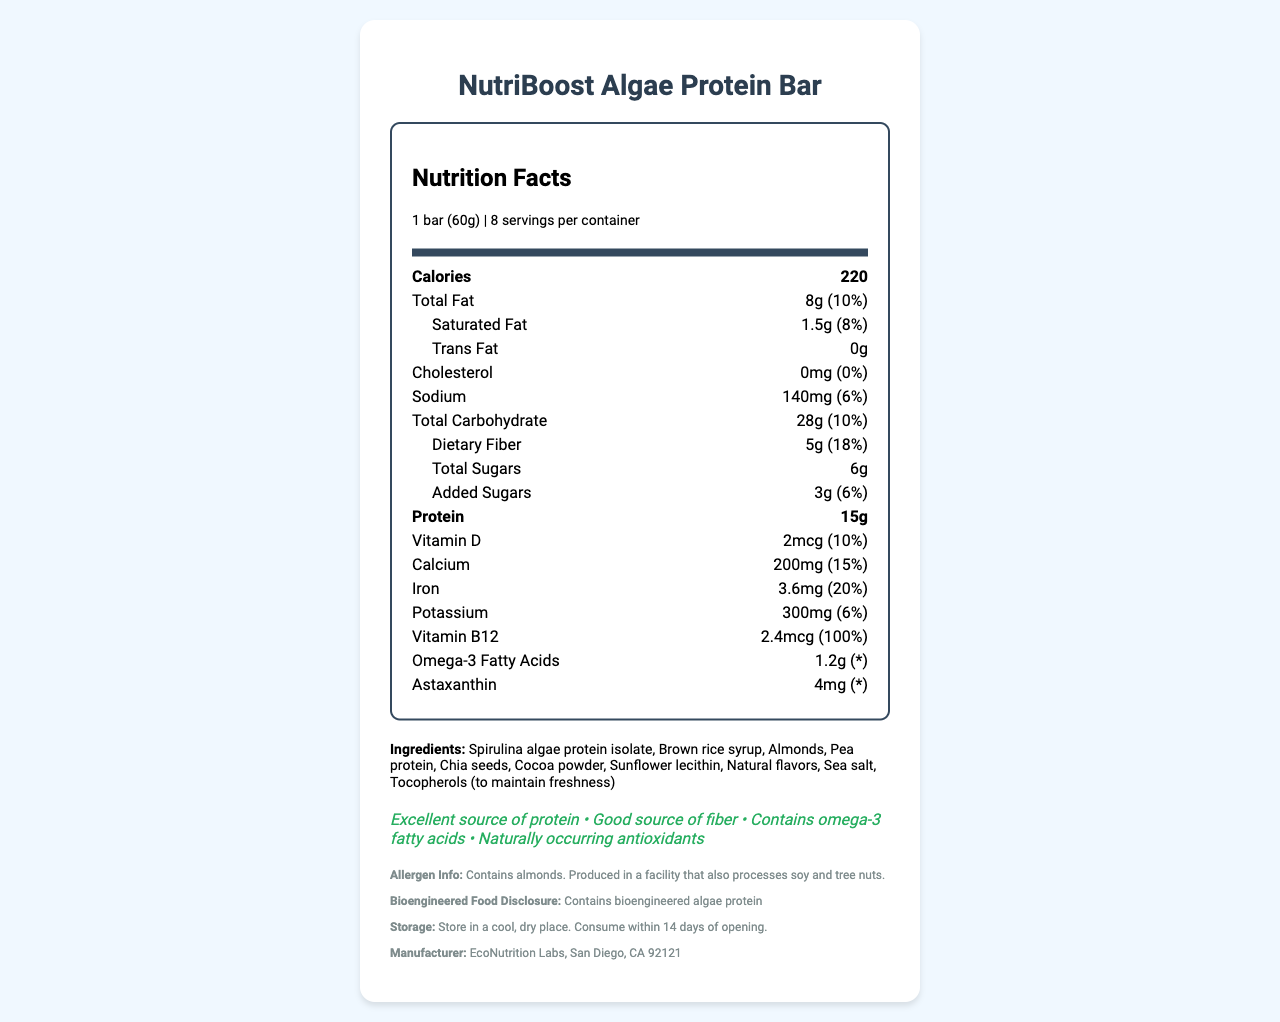what is the serving size of the NutriBoost Algae Protein Bar? The serving size is clearly mentioned at the top of the Nutrition Facts section of the document.
Answer: 1 bar (60g) how many calories are there per serving? The document lists the number of calories per serving at the top of the Nutrition Facts section.
Answer: 220 What percentage of the daily value for dietary fiber does one serving provide? The Nutrition Facts state that one serving provides 5g of dietary fiber, which is 18% of the daily value.
Answer: 18% Are there any trans fats in the NutriBoost Algae Protein Bar? The Nutrition Facts section lists "Trans Fat" as 0g.
Answer: No How much protein does one bar contain? The Nutrition Facts section shows that each bar contains 15g of protein.
Answer: 15g Which ingredient is used to maintain freshness? The ingredients list includes "Tocopherols (to maintain freshness)."
Answer: Tocopherols What is the daily value percentage for iron in one serving? The Nutrition Facts section lists iron as providing 3.6mg, which is 20% of the daily value.
Answer: 20% What is one of the health claims made about the NutriBoost Algae Protein Bar? The health claim section lists several claims, one of which is "Excellent source of protein."
Answer: Excellent source of protein Which of the following is NOT an ingredient in the NutriBoost Algae Protein Bar? A. Brown rice syrup B. Almonds C. Milk D. Chia seeds The ingredients list shows "Spirulina algae protein isolate, Brown rice syrup, Almonds, Pea protein, Chia seeds," but does not list milk.
Answer: C How should the NutriBoost Algae Protein Bar be stored? A. In a refrigerator B. In the freezer C. In a cool, dry place D. In a warm, humid place The storage instructions state "Store in a cool, dry place."
Answer: C Does the NutriBoost Algae Protein Bar contain bioengineered components? The Bioengineered Food Disclosure section clearly mentions "Contains bioengineered algae protein."
Answer: Yes Does one serving of this bar provide more than 300 calories? The calorie content per serving is listed as 220 calories.
Answer: No Summarize the key nutritional and ingredient information of the NutriBoost Algae Protein Bar. The key nutritional and ingredient information is derived from the Nutrition Facts, ingredients list, and health claims sections.
Answer: The NutriBoost Algae Protein Bar provides 220 calories per serving and contains 8g of total fat, 1.5g of saturated fat, 0g of trans fat, 0mg of cholesterol, 140mg of sodium, 28g of total carbohydrates, 5g of dietary fiber, 6g of total sugars (including 3g of added sugars), and 15g of protein. It includes notable amounts of vitamins and minerals such as Vitamin D, Calcium, Iron, and Vitamin B12. Main ingredients are Spirulina algae protein isolate, brown rice syrup, almonds, pea protein, chia seeds, cocoa powder, sunflower lecithin, natural flavors, sea salt, and tocopherols. Health claims highlight it as an excellent source of protein, good source of fiber, containing omega-3 fatty acids, and having naturally occurring antioxidants. What is the price of a single NutriBoost Algae Protein Bar? The document does not provide any information about the price of a single bar.
Answer: Cannot be determined 